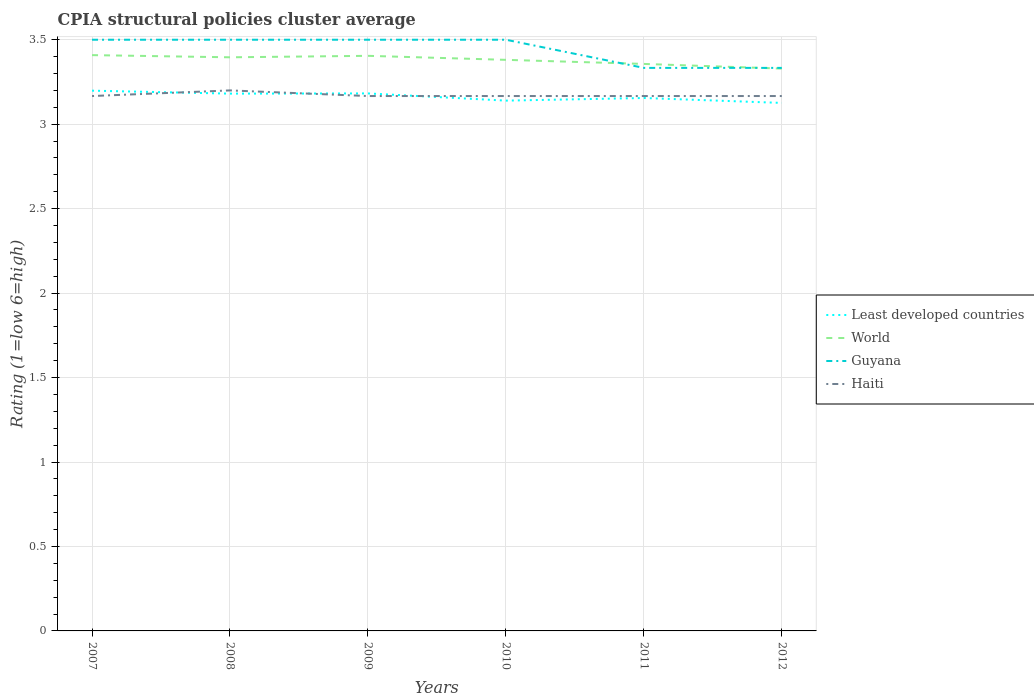How many different coloured lines are there?
Offer a very short reply. 4. Does the line corresponding to Least developed countries intersect with the line corresponding to Guyana?
Your answer should be compact. No. Is the number of lines equal to the number of legend labels?
Your answer should be compact. Yes. Across all years, what is the maximum CPIA rating in Least developed countries?
Provide a short and direct response. 3.13. What is the total CPIA rating in Haiti in the graph?
Ensure brevity in your answer.  0. What is the difference between the highest and the second highest CPIA rating in Guyana?
Make the answer very short. 0.17. How many legend labels are there?
Offer a terse response. 4. How are the legend labels stacked?
Offer a very short reply. Vertical. What is the title of the graph?
Offer a very short reply. CPIA structural policies cluster average. Does "Middle income" appear as one of the legend labels in the graph?
Your answer should be very brief. No. What is the label or title of the X-axis?
Ensure brevity in your answer.  Years. What is the label or title of the Y-axis?
Provide a short and direct response. Rating (1=low 6=high). What is the Rating (1=low 6=high) in Least developed countries in 2007?
Your answer should be compact. 3.2. What is the Rating (1=low 6=high) of World in 2007?
Your answer should be very brief. 3.41. What is the Rating (1=low 6=high) of Guyana in 2007?
Your answer should be compact. 3.5. What is the Rating (1=low 6=high) of Haiti in 2007?
Your answer should be very brief. 3.17. What is the Rating (1=low 6=high) of Least developed countries in 2008?
Provide a short and direct response. 3.18. What is the Rating (1=low 6=high) in World in 2008?
Keep it short and to the point. 3.4. What is the Rating (1=low 6=high) in Guyana in 2008?
Provide a short and direct response. 3.5. What is the Rating (1=low 6=high) in Least developed countries in 2009?
Your answer should be very brief. 3.18. What is the Rating (1=low 6=high) in World in 2009?
Your answer should be very brief. 3.4. What is the Rating (1=low 6=high) of Guyana in 2009?
Keep it short and to the point. 3.5. What is the Rating (1=low 6=high) of Haiti in 2009?
Your answer should be compact. 3.17. What is the Rating (1=low 6=high) of Least developed countries in 2010?
Provide a short and direct response. 3.14. What is the Rating (1=low 6=high) in World in 2010?
Offer a very short reply. 3.38. What is the Rating (1=low 6=high) in Guyana in 2010?
Provide a succinct answer. 3.5. What is the Rating (1=low 6=high) of Haiti in 2010?
Provide a succinct answer. 3.17. What is the Rating (1=low 6=high) in Least developed countries in 2011?
Your response must be concise. 3.16. What is the Rating (1=low 6=high) of World in 2011?
Provide a short and direct response. 3.36. What is the Rating (1=low 6=high) of Guyana in 2011?
Your response must be concise. 3.33. What is the Rating (1=low 6=high) of Haiti in 2011?
Ensure brevity in your answer.  3.17. What is the Rating (1=low 6=high) of Least developed countries in 2012?
Your answer should be very brief. 3.13. What is the Rating (1=low 6=high) of World in 2012?
Your answer should be compact. 3.33. What is the Rating (1=low 6=high) in Guyana in 2012?
Make the answer very short. 3.33. What is the Rating (1=low 6=high) of Haiti in 2012?
Give a very brief answer. 3.17. Across all years, what is the maximum Rating (1=low 6=high) of Least developed countries?
Your response must be concise. 3.2. Across all years, what is the maximum Rating (1=low 6=high) of World?
Keep it short and to the point. 3.41. Across all years, what is the maximum Rating (1=low 6=high) in Guyana?
Your answer should be compact. 3.5. Across all years, what is the maximum Rating (1=low 6=high) in Haiti?
Provide a succinct answer. 3.2. Across all years, what is the minimum Rating (1=low 6=high) of Least developed countries?
Provide a short and direct response. 3.13. Across all years, what is the minimum Rating (1=low 6=high) of World?
Ensure brevity in your answer.  3.33. Across all years, what is the minimum Rating (1=low 6=high) of Guyana?
Your response must be concise. 3.33. Across all years, what is the minimum Rating (1=low 6=high) in Haiti?
Give a very brief answer. 3.17. What is the total Rating (1=low 6=high) in Least developed countries in the graph?
Give a very brief answer. 18.98. What is the total Rating (1=low 6=high) of World in the graph?
Keep it short and to the point. 20.28. What is the total Rating (1=low 6=high) in Guyana in the graph?
Your answer should be very brief. 20.67. What is the total Rating (1=low 6=high) in Haiti in the graph?
Give a very brief answer. 19.03. What is the difference between the Rating (1=low 6=high) in Least developed countries in 2007 and that in 2008?
Ensure brevity in your answer.  0.02. What is the difference between the Rating (1=low 6=high) in World in 2007 and that in 2008?
Your response must be concise. 0.01. What is the difference between the Rating (1=low 6=high) in Guyana in 2007 and that in 2008?
Keep it short and to the point. 0. What is the difference between the Rating (1=low 6=high) of Haiti in 2007 and that in 2008?
Make the answer very short. -0.03. What is the difference between the Rating (1=low 6=high) of Least developed countries in 2007 and that in 2009?
Your response must be concise. 0.02. What is the difference between the Rating (1=low 6=high) in World in 2007 and that in 2009?
Offer a very short reply. 0. What is the difference between the Rating (1=low 6=high) of Least developed countries in 2007 and that in 2010?
Ensure brevity in your answer.  0.06. What is the difference between the Rating (1=low 6=high) in World in 2007 and that in 2010?
Give a very brief answer. 0.03. What is the difference between the Rating (1=low 6=high) in Least developed countries in 2007 and that in 2011?
Offer a terse response. 0.04. What is the difference between the Rating (1=low 6=high) of World in 2007 and that in 2011?
Your answer should be compact. 0.05. What is the difference between the Rating (1=low 6=high) of Guyana in 2007 and that in 2011?
Your answer should be very brief. 0.17. What is the difference between the Rating (1=low 6=high) in Least developed countries in 2007 and that in 2012?
Your answer should be compact. 0.07. What is the difference between the Rating (1=low 6=high) in World in 2007 and that in 2012?
Keep it short and to the point. 0.08. What is the difference between the Rating (1=low 6=high) of Guyana in 2007 and that in 2012?
Offer a very short reply. 0.17. What is the difference between the Rating (1=low 6=high) in Least developed countries in 2008 and that in 2009?
Offer a very short reply. -0. What is the difference between the Rating (1=low 6=high) of World in 2008 and that in 2009?
Keep it short and to the point. -0.01. What is the difference between the Rating (1=low 6=high) in Haiti in 2008 and that in 2009?
Ensure brevity in your answer.  0.03. What is the difference between the Rating (1=low 6=high) in Least developed countries in 2008 and that in 2010?
Offer a terse response. 0.04. What is the difference between the Rating (1=low 6=high) in World in 2008 and that in 2010?
Offer a very short reply. 0.01. What is the difference between the Rating (1=low 6=high) of Guyana in 2008 and that in 2010?
Offer a terse response. 0. What is the difference between the Rating (1=low 6=high) in Least developed countries in 2008 and that in 2011?
Keep it short and to the point. 0.03. What is the difference between the Rating (1=low 6=high) of World in 2008 and that in 2011?
Keep it short and to the point. 0.04. What is the difference between the Rating (1=low 6=high) of Guyana in 2008 and that in 2011?
Keep it short and to the point. 0.17. What is the difference between the Rating (1=low 6=high) of Least developed countries in 2008 and that in 2012?
Offer a very short reply. 0.06. What is the difference between the Rating (1=low 6=high) in World in 2008 and that in 2012?
Give a very brief answer. 0.07. What is the difference between the Rating (1=low 6=high) in Least developed countries in 2009 and that in 2010?
Ensure brevity in your answer.  0.04. What is the difference between the Rating (1=low 6=high) of World in 2009 and that in 2010?
Your answer should be very brief. 0.02. What is the difference between the Rating (1=low 6=high) in Guyana in 2009 and that in 2010?
Provide a succinct answer. 0. What is the difference between the Rating (1=low 6=high) in Least developed countries in 2009 and that in 2011?
Give a very brief answer. 0.03. What is the difference between the Rating (1=low 6=high) in World in 2009 and that in 2011?
Your response must be concise. 0.05. What is the difference between the Rating (1=low 6=high) of Haiti in 2009 and that in 2011?
Keep it short and to the point. 0. What is the difference between the Rating (1=low 6=high) in Least developed countries in 2009 and that in 2012?
Provide a short and direct response. 0.06. What is the difference between the Rating (1=low 6=high) in World in 2009 and that in 2012?
Provide a short and direct response. 0.08. What is the difference between the Rating (1=low 6=high) in Least developed countries in 2010 and that in 2011?
Your answer should be compact. -0.02. What is the difference between the Rating (1=low 6=high) in World in 2010 and that in 2011?
Provide a succinct answer. 0.02. What is the difference between the Rating (1=low 6=high) in Least developed countries in 2010 and that in 2012?
Offer a very short reply. 0.01. What is the difference between the Rating (1=low 6=high) of World in 2010 and that in 2012?
Provide a short and direct response. 0.05. What is the difference between the Rating (1=low 6=high) in Guyana in 2010 and that in 2012?
Give a very brief answer. 0.17. What is the difference between the Rating (1=low 6=high) of Least developed countries in 2011 and that in 2012?
Offer a terse response. 0.03. What is the difference between the Rating (1=low 6=high) in World in 2011 and that in 2012?
Make the answer very short. 0.03. What is the difference between the Rating (1=low 6=high) in Guyana in 2011 and that in 2012?
Your answer should be compact. 0. What is the difference between the Rating (1=low 6=high) of Least developed countries in 2007 and the Rating (1=low 6=high) of World in 2008?
Ensure brevity in your answer.  -0.2. What is the difference between the Rating (1=low 6=high) of Least developed countries in 2007 and the Rating (1=low 6=high) of Guyana in 2008?
Give a very brief answer. -0.3. What is the difference between the Rating (1=low 6=high) in Least developed countries in 2007 and the Rating (1=low 6=high) in Haiti in 2008?
Your answer should be compact. -0. What is the difference between the Rating (1=low 6=high) of World in 2007 and the Rating (1=low 6=high) of Guyana in 2008?
Offer a very short reply. -0.09. What is the difference between the Rating (1=low 6=high) of World in 2007 and the Rating (1=low 6=high) of Haiti in 2008?
Give a very brief answer. 0.21. What is the difference between the Rating (1=low 6=high) in Guyana in 2007 and the Rating (1=low 6=high) in Haiti in 2008?
Keep it short and to the point. 0.3. What is the difference between the Rating (1=low 6=high) in Least developed countries in 2007 and the Rating (1=low 6=high) in World in 2009?
Offer a very short reply. -0.21. What is the difference between the Rating (1=low 6=high) in Least developed countries in 2007 and the Rating (1=low 6=high) in Guyana in 2009?
Make the answer very short. -0.3. What is the difference between the Rating (1=low 6=high) of Least developed countries in 2007 and the Rating (1=low 6=high) of Haiti in 2009?
Provide a succinct answer. 0.03. What is the difference between the Rating (1=low 6=high) of World in 2007 and the Rating (1=low 6=high) of Guyana in 2009?
Ensure brevity in your answer.  -0.09. What is the difference between the Rating (1=low 6=high) of World in 2007 and the Rating (1=low 6=high) of Haiti in 2009?
Offer a terse response. 0.24. What is the difference between the Rating (1=low 6=high) of Guyana in 2007 and the Rating (1=low 6=high) of Haiti in 2009?
Your answer should be compact. 0.33. What is the difference between the Rating (1=low 6=high) in Least developed countries in 2007 and the Rating (1=low 6=high) in World in 2010?
Make the answer very short. -0.18. What is the difference between the Rating (1=low 6=high) of Least developed countries in 2007 and the Rating (1=low 6=high) of Guyana in 2010?
Ensure brevity in your answer.  -0.3. What is the difference between the Rating (1=low 6=high) of Least developed countries in 2007 and the Rating (1=low 6=high) of Haiti in 2010?
Your answer should be compact. 0.03. What is the difference between the Rating (1=low 6=high) in World in 2007 and the Rating (1=low 6=high) in Guyana in 2010?
Your answer should be very brief. -0.09. What is the difference between the Rating (1=low 6=high) of World in 2007 and the Rating (1=low 6=high) of Haiti in 2010?
Make the answer very short. 0.24. What is the difference between the Rating (1=low 6=high) in Guyana in 2007 and the Rating (1=low 6=high) in Haiti in 2010?
Your answer should be very brief. 0.33. What is the difference between the Rating (1=low 6=high) in Least developed countries in 2007 and the Rating (1=low 6=high) in World in 2011?
Offer a terse response. -0.16. What is the difference between the Rating (1=low 6=high) in Least developed countries in 2007 and the Rating (1=low 6=high) in Guyana in 2011?
Provide a succinct answer. -0.13. What is the difference between the Rating (1=low 6=high) in Least developed countries in 2007 and the Rating (1=low 6=high) in Haiti in 2011?
Your response must be concise. 0.03. What is the difference between the Rating (1=low 6=high) of World in 2007 and the Rating (1=low 6=high) of Guyana in 2011?
Make the answer very short. 0.08. What is the difference between the Rating (1=low 6=high) in World in 2007 and the Rating (1=low 6=high) in Haiti in 2011?
Your answer should be very brief. 0.24. What is the difference between the Rating (1=low 6=high) in Guyana in 2007 and the Rating (1=low 6=high) in Haiti in 2011?
Offer a very short reply. 0.33. What is the difference between the Rating (1=low 6=high) in Least developed countries in 2007 and the Rating (1=low 6=high) in World in 2012?
Ensure brevity in your answer.  -0.13. What is the difference between the Rating (1=low 6=high) in Least developed countries in 2007 and the Rating (1=low 6=high) in Guyana in 2012?
Ensure brevity in your answer.  -0.13. What is the difference between the Rating (1=low 6=high) of Least developed countries in 2007 and the Rating (1=low 6=high) of Haiti in 2012?
Your answer should be very brief. 0.03. What is the difference between the Rating (1=low 6=high) in World in 2007 and the Rating (1=low 6=high) in Guyana in 2012?
Make the answer very short. 0.08. What is the difference between the Rating (1=low 6=high) of World in 2007 and the Rating (1=low 6=high) of Haiti in 2012?
Your answer should be compact. 0.24. What is the difference between the Rating (1=low 6=high) in Guyana in 2007 and the Rating (1=low 6=high) in Haiti in 2012?
Offer a very short reply. 0.33. What is the difference between the Rating (1=low 6=high) of Least developed countries in 2008 and the Rating (1=low 6=high) of World in 2009?
Offer a terse response. -0.22. What is the difference between the Rating (1=low 6=high) in Least developed countries in 2008 and the Rating (1=low 6=high) in Guyana in 2009?
Your answer should be very brief. -0.32. What is the difference between the Rating (1=low 6=high) of Least developed countries in 2008 and the Rating (1=low 6=high) of Haiti in 2009?
Provide a short and direct response. 0.01. What is the difference between the Rating (1=low 6=high) in World in 2008 and the Rating (1=low 6=high) in Guyana in 2009?
Offer a terse response. -0.1. What is the difference between the Rating (1=low 6=high) in World in 2008 and the Rating (1=low 6=high) in Haiti in 2009?
Ensure brevity in your answer.  0.23. What is the difference between the Rating (1=low 6=high) of Least developed countries in 2008 and the Rating (1=low 6=high) of World in 2010?
Offer a very short reply. -0.2. What is the difference between the Rating (1=low 6=high) in Least developed countries in 2008 and the Rating (1=low 6=high) in Guyana in 2010?
Offer a terse response. -0.32. What is the difference between the Rating (1=low 6=high) in Least developed countries in 2008 and the Rating (1=low 6=high) in Haiti in 2010?
Provide a succinct answer. 0.01. What is the difference between the Rating (1=low 6=high) of World in 2008 and the Rating (1=low 6=high) of Guyana in 2010?
Provide a short and direct response. -0.1. What is the difference between the Rating (1=low 6=high) of World in 2008 and the Rating (1=low 6=high) of Haiti in 2010?
Offer a terse response. 0.23. What is the difference between the Rating (1=low 6=high) of Guyana in 2008 and the Rating (1=low 6=high) of Haiti in 2010?
Offer a terse response. 0.33. What is the difference between the Rating (1=low 6=high) of Least developed countries in 2008 and the Rating (1=low 6=high) of World in 2011?
Your response must be concise. -0.18. What is the difference between the Rating (1=low 6=high) in Least developed countries in 2008 and the Rating (1=low 6=high) in Guyana in 2011?
Ensure brevity in your answer.  -0.15. What is the difference between the Rating (1=low 6=high) of Least developed countries in 2008 and the Rating (1=low 6=high) of Haiti in 2011?
Give a very brief answer. 0.01. What is the difference between the Rating (1=low 6=high) of World in 2008 and the Rating (1=low 6=high) of Guyana in 2011?
Keep it short and to the point. 0.06. What is the difference between the Rating (1=low 6=high) in World in 2008 and the Rating (1=low 6=high) in Haiti in 2011?
Make the answer very short. 0.23. What is the difference between the Rating (1=low 6=high) of Least developed countries in 2008 and the Rating (1=low 6=high) of World in 2012?
Provide a short and direct response. -0.15. What is the difference between the Rating (1=low 6=high) of Least developed countries in 2008 and the Rating (1=low 6=high) of Guyana in 2012?
Your answer should be compact. -0.15. What is the difference between the Rating (1=low 6=high) in Least developed countries in 2008 and the Rating (1=low 6=high) in Haiti in 2012?
Ensure brevity in your answer.  0.01. What is the difference between the Rating (1=low 6=high) in World in 2008 and the Rating (1=low 6=high) in Guyana in 2012?
Offer a very short reply. 0.06. What is the difference between the Rating (1=low 6=high) of World in 2008 and the Rating (1=low 6=high) of Haiti in 2012?
Make the answer very short. 0.23. What is the difference between the Rating (1=low 6=high) in Least developed countries in 2009 and the Rating (1=low 6=high) in World in 2010?
Provide a short and direct response. -0.2. What is the difference between the Rating (1=low 6=high) in Least developed countries in 2009 and the Rating (1=low 6=high) in Guyana in 2010?
Your response must be concise. -0.32. What is the difference between the Rating (1=low 6=high) in Least developed countries in 2009 and the Rating (1=low 6=high) in Haiti in 2010?
Your answer should be very brief. 0.02. What is the difference between the Rating (1=low 6=high) in World in 2009 and the Rating (1=low 6=high) in Guyana in 2010?
Offer a terse response. -0.1. What is the difference between the Rating (1=low 6=high) in World in 2009 and the Rating (1=low 6=high) in Haiti in 2010?
Provide a short and direct response. 0.24. What is the difference between the Rating (1=low 6=high) of Guyana in 2009 and the Rating (1=low 6=high) of Haiti in 2010?
Provide a succinct answer. 0.33. What is the difference between the Rating (1=low 6=high) of Least developed countries in 2009 and the Rating (1=low 6=high) of World in 2011?
Give a very brief answer. -0.17. What is the difference between the Rating (1=low 6=high) in Least developed countries in 2009 and the Rating (1=low 6=high) in Guyana in 2011?
Your response must be concise. -0.15. What is the difference between the Rating (1=low 6=high) in Least developed countries in 2009 and the Rating (1=low 6=high) in Haiti in 2011?
Offer a very short reply. 0.02. What is the difference between the Rating (1=low 6=high) of World in 2009 and the Rating (1=low 6=high) of Guyana in 2011?
Provide a short and direct response. 0.07. What is the difference between the Rating (1=low 6=high) in World in 2009 and the Rating (1=low 6=high) in Haiti in 2011?
Give a very brief answer. 0.24. What is the difference between the Rating (1=low 6=high) in Least developed countries in 2009 and the Rating (1=low 6=high) in World in 2012?
Offer a terse response. -0.15. What is the difference between the Rating (1=low 6=high) of Least developed countries in 2009 and the Rating (1=low 6=high) of Guyana in 2012?
Make the answer very short. -0.15. What is the difference between the Rating (1=low 6=high) in Least developed countries in 2009 and the Rating (1=low 6=high) in Haiti in 2012?
Offer a terse response. 0.02. What is the difference between the Rating (1=low 6=high) in World in 2009 and the Rating (1=low 6=high) in Guyana in 2012?
Give a very brief answer. 0.07. What is the difference between the Rating (1=low 6=high) of World in 2009 and the Rating (1=low 6=high) of Haiti in 2012?
Give a very brief answer. 0.24. What is the difference between the Rating (1=low 6=high) of Guyana in 2009 and the Rating (1=low 6=high) of Haiti in 2012?
Your answer should be compact. 0.33. What is the difference between the Rating (1=low 6=high) of Least developed countries in 2010 and the Rating (1=low 6=high) of World in 2011?
Offer a very short reply. -0.22. What is the difference between the Rating (1=low 6=high) of Least developed countries in 2010 and the Rating (1=low 6=high) of Guyana in 2011?
Provide a succinct answer. -0.19. What is the difference between the Rating (1=low 6=high) in Least developed countries in 2010 and the Rating (1=low 6=high) in Haiti in 2011?
Provide a short and direct response. -0.03. What is the difference between the Rating (1=low 6=high) in World in 2010 and the Rating (1=low 6=high) in Guyana in 2011?
Your response must be concise. 0.05. What is the difference between the Rating (1=low 6=high) of World in 2010 and the Rating (1=low 6=high) of Haiti in 2011?
Your response must be concise. 0.21. What is the difference between the Rating (1=low 6=high) of Guyana in 2010 and the Rating (1=low 6=high) of Haiti in 2011?
Your response must be concise. 0.33. What is the difference between the Rating (1=low 6=high) of Least developed countries in 2010 and the Rating (1=low 6=high) of World in 2012?
Your answer should be very brief. -0.19. What is the difference between the Rating (1=low 6=high) of Least developed countries in 2010 and the Rating (1=low 6=high) of Guyana in 2012?
Your response must be concise. -0.19. What is the difference between the Rating (1=low 6=high) of Least developed countries in 2010 and the Rating (1=low 6=high) of Haiti in 2012?
Offer a terse response. -0.03. What is the difference between the Rating (1=low 6=high) of World in 2010 and the Rating (1=low 6=high) of Guyana in 2012?
Ensure brevity in your answer.  0.05. What is the difference between the Rating (1=low 6=high) of World in 2010 and the Rating (1=low 6=high) of Haiti in 2012?
Ensure brevity in your answer.  0.21. What is the difference between the Rating (1=low 6=high) in Guyana in 2010 and the Rating (1=low 6=high) in Haiti in 2012?
Provide a succinct answer. 0.33. What is the difference between the Rating (1=low 6=high) in Least developed countries in 2011 and the Rating (1=low 6=high) in World in 2012?
Provide a short and direct response. -0.17. What is the difference between the Rating (1=low 6=high) in Least developed countries in 2011 and the Rating (1=low 6=high) in Guyana in 2012?
Ensure brevity in your answer.  -0.18. What is the difference between the Rating (1=low 6=high) in Least developed countries in 2011 and the Rating (1=low 6=high) in Haiti in 2012?
Your response must be concise. -0.01. What is the difference between the Rating (1=low 6=high) of World in 2011 and the Rating (1=low 6=high) of Guyana in 2012?
Your answer should be compact. 0.02. What is the difference between the Rating (1=low 6=high) in World in 2011 and the Rating (1=low 6=high) in Haiti in 2012?
Your answer should be very brief. 0.19. What is the difference between the Rating (1=low 6=high) in Guyana in 2011 and the Rating (1=low 6=high) in Haiti in 2012?
Your answer should be compact. 0.17. What is the average Rating (1=low 6=high) in Least developed countries per year?
Offer a terse response. 3.16. What is the average Rating (1=low 6=high) of World per year?
Your answer should be compact. 3.38. What is the average Rating (1=low 6=high) in Guyana per year?
Give a very brief answer. 3.44. What is the average Rating (1=low 6=high) in Haiti per year?
Provide a succinct answer. 3.17. In the year 2007, what is the difference between the Rating (1=low 6=high) of Least developed countries and Rating (1=low 6=high) of World?
Your answer should be very brief. -0.21. In the year 2007, what is the difference between the Rating (1=low 6=high) of Least developed countries and Rating (1=low 6=high) of Guyana?
Your response must be concise. -0.3. In the year 2007, what is the difference between the Rating (1=low 6=high) in Least developed countries and Rating (1=low 6=high) in Haiti?
Give a very brief answer. 0.03. In the year 2007, what is the difference between the Rating (1=low 6=high) of World and Rating (1=low 6=high) of Guyana?
Your response must be concise. -0.09. In the year 2007, what is the difference between the Rating (1=low 6=high) in World and Rating (1=low 6=high) in Haiti?
Make the answer very short. 0.24. In the year 2008, what is the difference between the Rating (1=low 6=high) in Least developed countries and Rating (1=low 6=high) in World?
Make the answer very short. -0.21. In the year 2008, what is the difference between the Rating (1=low 6=high) of Least developed countries and Rating (1=low 6=high) of Guyana?
Your answer should be compact. -0.32. In the year 2008, what is the difference between the Rating (1=low 6=high) of Least developed countries and Rating (1=low 6=high) of Haiti?
Offer a terse response. -0.02. In the year 2008, what is the difference between the Rating (1=low 6=high) of World and Rating (1=low 6=high) of Guyana?
Provide a short and direct response. -0.1. In the year 2008, what is the difference between the Rating (1=low 6=high) in World and Rating (1=low 6=high) in Haiti?
Make the answer very short. 0.2. In the year 2009, what is the difference between the Rating (1=low 6=high) in Least developed countries and Rating (1=low 6=high) in World?
Give a very brief answer. -0.22. In the year 2009, what is the difference between the Rating (1=low 6=high) of Least developed countries and Rating (1=low 6=high) of Guyana?
Provide a succinct answer. -0.32. In the year 2009, what is the difference between the Rating (1=low 6=high) in Least developed countries and Rating (1=low 6=high) in Haiti?
Make the answer very short. 0.02. In the year 2009, what is the difference between the Rating (1=low 6=high) of World and Rating (1=low 6=high) of Guyana?
Give a very brief answer. -0.1. In the year 2009, what is the difference between the Rating (1=low 6=high) in World and Rating (1=low 6=high) in Haiti?
Offer a terse response. 0.24. In the year 2010, what is the difference between the Rating (1=low 6=high) in Least developed countries and Rating (1=low 6=high) in World?
Keep it short and to the point. -0.24. In the year 2010, what is the difference between the Rating (1=low 6=high) of Least developed countries and Rating (1=low 6=high) of Guyana?
Make the answer very short. -0.36. In the year 2010, what is the difference between the Rating (1=low 6=high) of Least developed countries and Rating (1=low 6=high) of Haiti?
Your response must be concise. -0.03. In the year 2010, what is the difference between the Rating (1=low 6=high) of World and Rating (1=low 6=high) of Guyana?
Make the answer very short. -0.12. In the year 2010, what is the difference between the Rating (1=low 6=high) in World and Rating (1=low 6=high) in Haiti?
Make the answer very short. 0.21. In the year 2011, what is the difference between the Rating (1=low 6=high) in Least developed countries and Rating (1=low 6=high) in World?
Provide a short and direct response. -0.2. In the year 2011, what is the difference between the Rating (1=low 6=high) of Least developed countries and Rating (1=low 6=high) of Guyana?
Ensure brevity in your answer.  -0.18. In the year 2011, what is the difference between the Rating (1=low 6=high) of Least developed countries and Rating (1=low 6=high) of Haiti?
Offer a terse response. -0.01. In the year 2011, what is the difference between the Rating (1=low 6=high) in World and Rating (1=low 6=high) in Guyana?
Provide a succinct answer. 0.02. In the year 2011, what is the difference between the Rating (1=low 6=high) of World and Rating (1=low 6=high) of Haiti?
Keep it short and to the point. 0.19. In the year 2011, what is the difference between the Rating (1=low 6=high) of Guyana and Rating (1=low 6=high) of Haiti?
Provide a succinct answer. 0.17. In the year 2012, what is the difference between the Rating (1=low 6=high) in Least developed countries and Rating (1=low 6=high) in World?
Your response must be concise. -0.2. In the year 2012, what is the difference between the Rating (1=low 6=high) of Least developed countries and Rating (1=low 6=high) of Guyana?
Offer a terse response. -0.21. In the year 2012, what is the difference between the Rating (1=low 6=high) in Least developed countries and Rating (1=low 6=high) in Haiti?
Provide a short and direct response. -0.04. In the year 2012, what is the difference between the Rating (1=low 6=high) of World and Rating (1=low 6=high) of Guyana?
Your response must be concise. -0. In the year 2012, what is the difference between the Rating (1=low 6=high) of World and Rating (1=low 6=high) of Haiti?
Your answer should be compact. 0.16. What is the ratio of the Rating (1=low 6=high) of Guyana in 2007 to that in 2008?
Your answer should be compact. 1. What is the ratio of the Rating (1=low 6=high) in Haiti in 2007 to that in 2008?
Your response must be concise. 0.99. What is the ratio of the Rating (1=low 6=high) of World in 2007 to that in 2009?
Your answer should be very brief. 1. What is the ratio of the Rating (1=low 6=high) of Guyana in 2007 to that in 2009?
Provide a short and direct response. 1. What is the ratio of the Rating (1=low 6=high) in Least developed countries in 2007 to that in 2010?
Ensure brevity in your answer.  1.02. What is the ratio of the Rating (1=low 6=high) in World in 2007 to that in 2010?
Keep it short and to the point. 1.01. What is the ratio of the Rating (1=low 6=high) in Guyana in 2007 to that in 2010?
Make the answer very short. 1. What is the ratio of the Rating (1=low 6=high) in Haiti in 2007 to that in 2010?
Give a very brief answer. 1. What is the ratio of the Rating (1=low 6=high) in Least developed countries in 2007 to that in 2011?
Ensure brevity in your answer.  1.01. What is the ratio of the Rating (1=low 6=high) of World in 2007 to that in 2011?
Make the answer very short. 1.02. What is the ratio of the Rating (1=low 6=high) in Guyana in 2007 to that in 2011?
Provide a short and direct response. 1.05. What is the ratio of the Rating (1=low 6=high) of Haiti in 2007 to that in 2011?
Your answer should be compact. 1. What is the ratio of the Rating (1=low 6=high) of Least developed countries in 2007 to that in 2012?
Provide a succinct answer. 1.02. What is the ratio of the Rating (1=low 6=high) of World in 2007 to that in 2012?
Offer a terse response. 1.02. What is the ratio of the Rating (1=low 6=high) in Guyana in 2007 to that in 2012?
Give a very brief answer. 1.05. What is the ratio of the Rating (1=low 6=high) of Haiti in 2007 to that in 2012?
Your response must be concise. 1. What is the ratio of the Rating (1=low 6=high) in Haiti in 2008 to that in 2009?
Keep it short and to the point. 1.01. What is the ratio of the Rating (1=low 6=high) of Least developed countries in 2008 to that in 2010?
Keep it short and to the point. 1.01. What is the ratio of the Rating (1=low 6=high) in World in 2008 to that in 2010?
Provide a short and direct response. 1. What is the ratio of the Rating (1=low 6=high) in Haiti in 2008 to that in 2010?
Give a very brief answer. 1.01. What is the ratio of the Rating (1=low 6=high) of Least developed countries in 2008 to that in 2011?
Offer a terse response. 1.01. What is the ratio of the Rating (1=low 6=high) in World in 2008 to that in 2011?
Give a very brief answer. 1.01. What is the ratio of the Rating (1=low 6=high) of Haiti in 2008 to that in 2011?
Offer a very short reply. 1.01. What is the ratio of the Rating (1=low 6=high) of Least developed countries in 2008 to that in 2012?
Your answer should be compact. 1.02. What is the ratio of the Rating (1=low 6=high) in World in 2008 to that in 2012?
Keep it short and to the point. 1.02. What is the ratio of the Rating (1=low 6=high) in Haiti in 2008 to that in 2012?
Offer a very short reply. 1.01. What is the ratio of the Rating (1=low 6=high) of Least developed countries in 2009 to that in 2010?
Provide a succinct answer. 1.01. What is the ratio of the Rating (1=low 6=high) in Haiti in 2009 to that in 2010?
Give a very brief answer. 1. What is the ratio of the Rating (1=low 6=high) in Least developed countries in 2009 to that in 2011?
Your answer should be compact. 1.01. What is the ratio of the Rating (1=low 6=high) of World in 2009 to that in 2011?
Give a very brief answer. 1.01. What is the ratio of the Rating (1=low 6=high) of Least developed countries in 2009 to that in 2012?
Keep it short and to the point. 1.02. What is the ratio of the Rating (1=low 6=high) in World in 2009 to that in 2012?
Offer a terse response. 1.02. What is the ratio of the Rating (1=low 6=high) of Guyana in 2009 to that in 2012?
Your response must be concise. 1.05. What is the ratio of the Rating (1=low 6=high) of Haiti in 2009 to that in 2012?
Give a very brief answer. 1. What is the ratio of the Rating (1=low 6=high) of Least developed countries in 2010 to that in 2011?
Your answer should be very brief. 1. What is the ratio of the Rating (1=low 6=high) of World in 2010 to that in 2011?
Your answer should be compact. 1.01. What is the ratio of the Rating (1=low 6=high) of Least developed countries in 2010 to that in 2012?
Offer a very short reply. 1. What is the ratio of the Rating (1=low 6=high) of World in 2010 to that in 2012?
Offer a terse response. 1.02. What is the ratio of the Rating (1=low 6=high) of Least developed countries in 2011 to that in 2012?
Your answer should be compact. 1.01. What is the ratio of the Rating (1=low 6=high) of World in 2011 to that in 2012?
Offer a terse response. 1.01. What is the ratio of the Rating (1=low 6=high) in Guyana in 2011 to that in 2012?
Offer a very short reply. 1. What is the difference between the highest and the second highest Rating (1=low 6=high) of Least developed countries?
Make the answer very short. 0.02. What is the difference between the highest and the second highest Rating (1=low 6=high) in World?
Give a very brief answer. 0. What is the difference between the highest and the second highest Rating (1=low 6=high) in Guyana?
Keep it short and to the point. 0. What is the difference between the highest and the lowest Rating (1=low 6=high) in Least developed countries?
Give a very brief answer. 0.07. What is the difference between the highest and the lowest Rating (1=low 6=high) of World?
Your response must be concise. 0.08. What is the difference between the highest and the lowest Rating (1=low 6=high) of Guyana?
Provide a short and direct response. 0.17. What is the difference between the highest and the lowest Rating (1=low 6=high) in Haiti?
Provide a short and direct response. 0.03. 